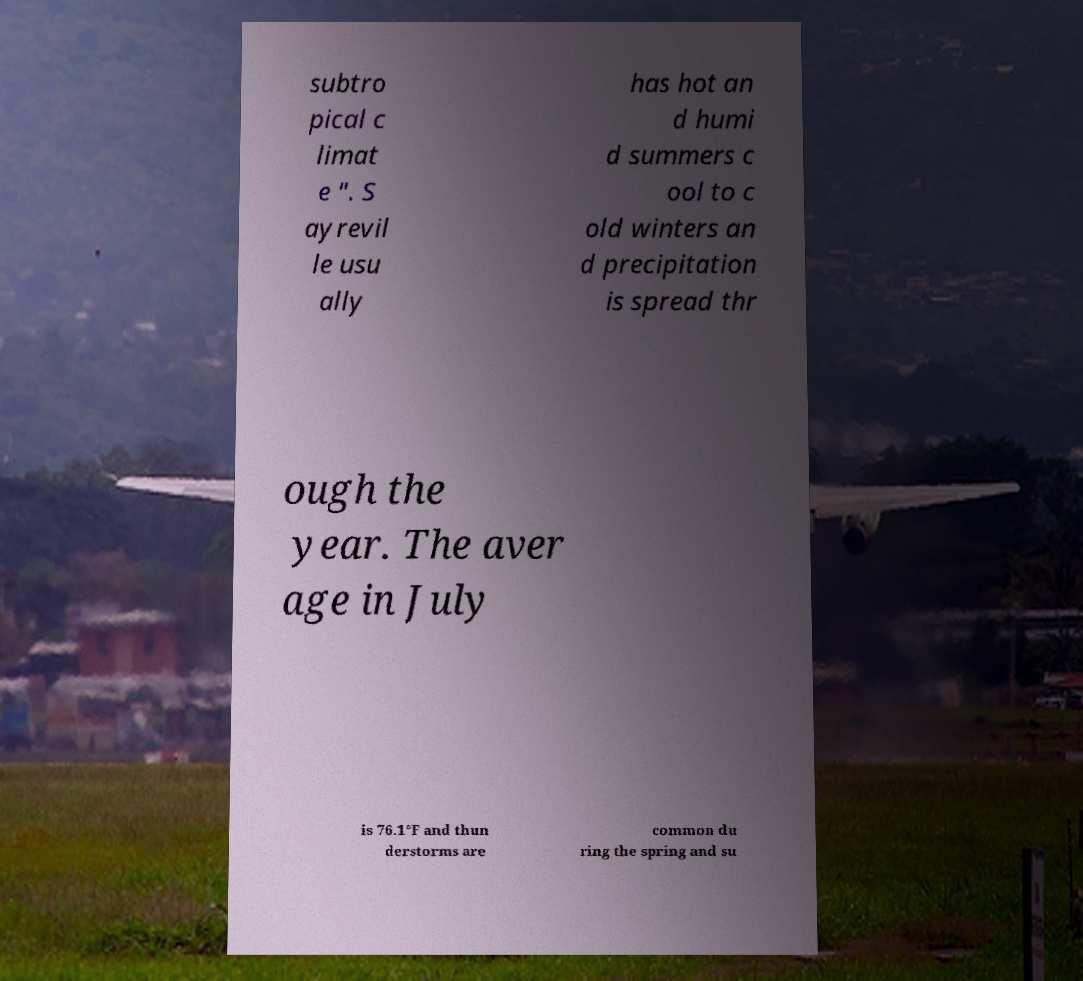Could you assist in decoding the text presented in this image and type it out clearly? subtro pical c limat e ". S ayrevil le usu ally has hot an d humi d summers c ool to c old winters an d precipitation is spread thr ough the year. The aver age in July is 76.1°F and thun derstorms are common du ring the spring and su 